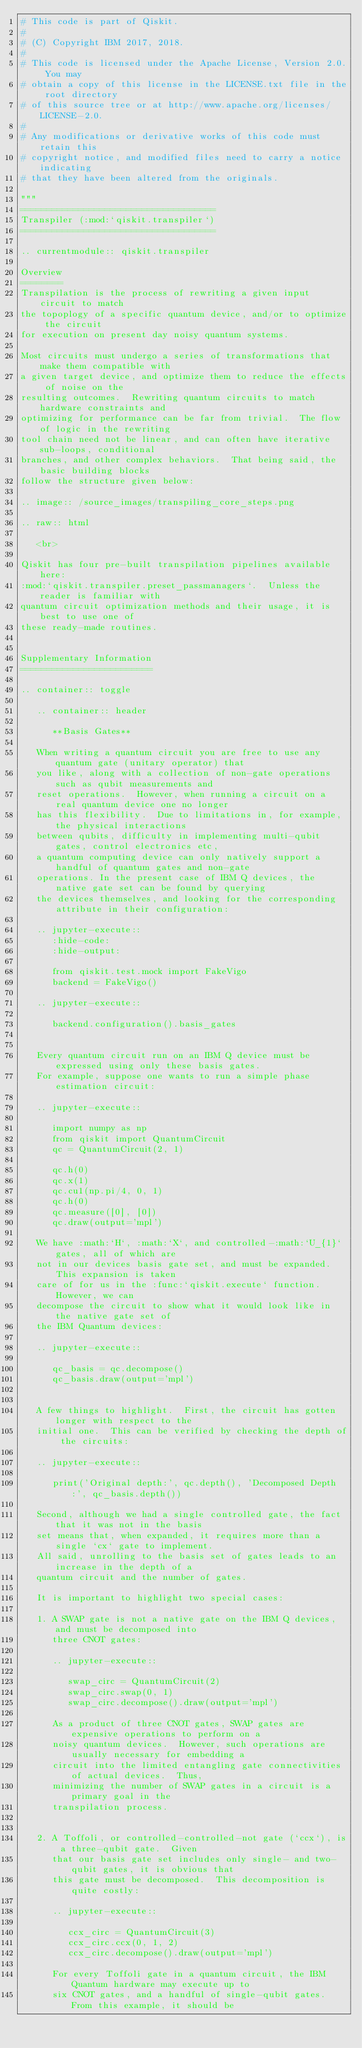Convert code to text. <code><loc_0><loc_0><loc_500><loc_500><_Python_># This code is part of Qiskit.
#
# (C) Copyright IBM 2017, 2018.
#
# This code is licensed under the Apache License, Version 2.0. You may
# obtain a copy of this license in the LICENSE.txt file in the root directory
# of this source tree or at http://www.apache.org/licenses/LICENSE-2.0.
#
# Any modifications or derivative works of this code must retain this
# copyright notice, and modified files need to carry a notice indicating
# that they have been altered from the originals.

"""
=====================================
Transpiler (:mod:`qiskit.transpiler`)
=====================================

.. currentmodule:: qiskit.transpiler

Overview
========
Transpilation is the process of rewriting a given input circuit to match
the topoplogy of a specific quantum device, and/or to optimize the circuit
for execution on present day noisy quantum systems.

Most circuits must undergo a series of transformations that make them compatible with
a given target device, and optimize them to reduce the effects of noise on the
resulting outcomes.  Rewriting quantum circuits to match hardware constraints and
optimizing for performance can be far from trivial.  The flow of logic in the rewriting
tool chain need not be linear, and can often have iterative sub-loops, conditional
branches, and other complex behaviors.  That being said, the basic building blocks
follow the structure given below:

.. image:: /source_images/transpiling_core_steps.png

.. raw:: html

   <br>

Qiskit has four pre-built transpilation pipelines available here:
:mod:`qiskit.transpiler.preset_passmanagers`.  Unless the reader is familiar with
quantum circuit optimization methods and their usage, it is best to use one of
these ready-made routines.


Supplementary Information
=========================

.. container:: toggle

   .. container:: header

      **Basis Gates**

   When writing a quantum circuit you are free to use any quantum gate (unitary operator) that
   you like, along with a collection of non-gate operations such as qubit measurements and
   reset operations.  However, when running a circuit on a real quantum device one no longer
   has this flexibility.  Due to limitations in, for example, the physical interactions
   between qubits, difficulty in implementing multi-qubit gates, control electronics etc,
   a quantum computing device can only natively support a handful of quantum gates and non-gate
   operations. In the present case of IBM Q devices, the native gate set can be found by querying
   the devices themselves, and looking for the corresponding attribute in their configuration:

   .. jupyter-execute::
      :hide-code:
      :hide-output:

      from qiskit.test.mock import FakeVigo
      backend = FakeVigo()

   .. jupyter-execute::

      backend.configuration().basis_gates


   Every quantum circuit run on an IBM Q device must be expressed using only these basis gates.
   For example, suppose one wants to run a simple phase estimation circuit:

   .. jupyter-execute::

      import numpy as np
      from qiskit import QuantumCircuit
      qc = QuantumCircuit(2, 1)

      qc.h(0)
      qc.x(1)
      qc.cu1(np.pi/4, 0, 1)
      qc.h(0)
      qc.measure([0], [0])
      qc.draw(output='mpl')

   We have :math:`H`, :math:`X`, and controlled-:math:`U_{1}` gates, all of which are
   not in our devices basis gate set, and must be expanded.  This expansion is taken
   care of for us in the :func:`qiskit.execute` function. However, we can
   decompose the circuit to show what it would look like in the native gate set of
   the IBM Quantum devices:

   .. jupyter-execute::

      qc_basis = qc.decompose()
      qc_basis.draw(output='mpl')


   A few things to highlight.  First, the circuit has gotten longer with respect to the
   initial one.  This can be verified by checking the depth of the circuits:

   .. jupyter-execute::

      print('Original depth:', qc.depth(), 'Decomposed Depth:', qc_basis.depth())

   Second, although we had a single controlled gate, the fact that it was not in the basis
   set means that, when expanded, it requires more than a single `cx` gate to implement.
   All said, unrolling to the basis set of gates leads to an increase in the depth of a
   quantum circuit and the number of gates.

   It is important to highlight two special cases:

   1. A SWAP gate is not a native gate on the IBM Q devices, and must be decomposed into
      three CNOT gates:

      .. jupyter-execute::

         swap_circ = QuantumCircuit(2)
         swap_circ.swap(0, 1)
         swap_circ.decompose().draw(output='mpl')

      As a product of three CNOT gates, SWAP gates are expensive operations to perform on a
      noisy quantum devices.  However, such operations are usually necessary for embedding a
      circuit into the limited entangling gate connectivities of actual devices.  Thus,
      minimizing the number of SWAP gates in a circuit is a primary goal in the
      transpilation process.


   2. A Toffoli, or controlled-controlled-not gate (`ccx`), is a three-qubit gate.  Given
      that our basis gate set includes only single- and two-qubit gates, it is obvious that
      this gate must be decomposed.  This decomposition is quite costly:

      .. jupyter-execute::

         ccx_circ = QuantumCircuit(3)
         ccx_circ.ccx(0, 1, 2)
         ccx_circ.decompose().draw(output='mpl')

      For every Toffoli gate in a quantum circuit, the IBM Quantum hardware may execute up to
      six CNOT gates, and a handful of single-qubit gates.  From this example, it should be</code> 